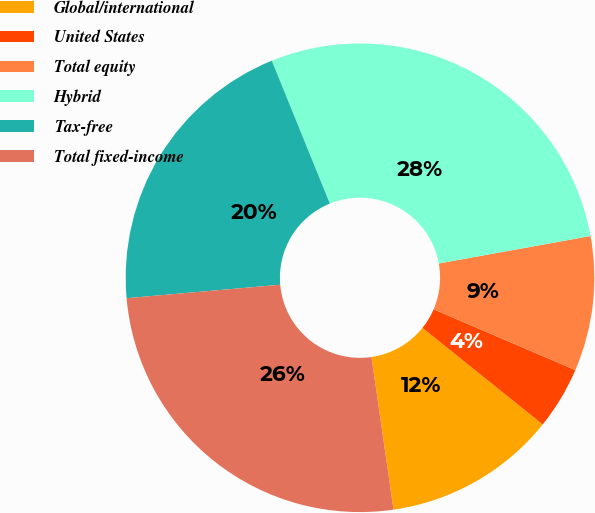<chart> <loc_0><loc_0><loc_500><loc_500><pie_chart><fcel>Global/international<fcel>United States<fcel>Total equity<fcel>Hybrid<fcel>Tax-free<fcel>Total fixed-income<nl><fcel>11.95%<fcel>4.32%<fcel>9.3%<fcel>28.29%<fcel>20.25%<fcel>25.9%<nl></chart> 